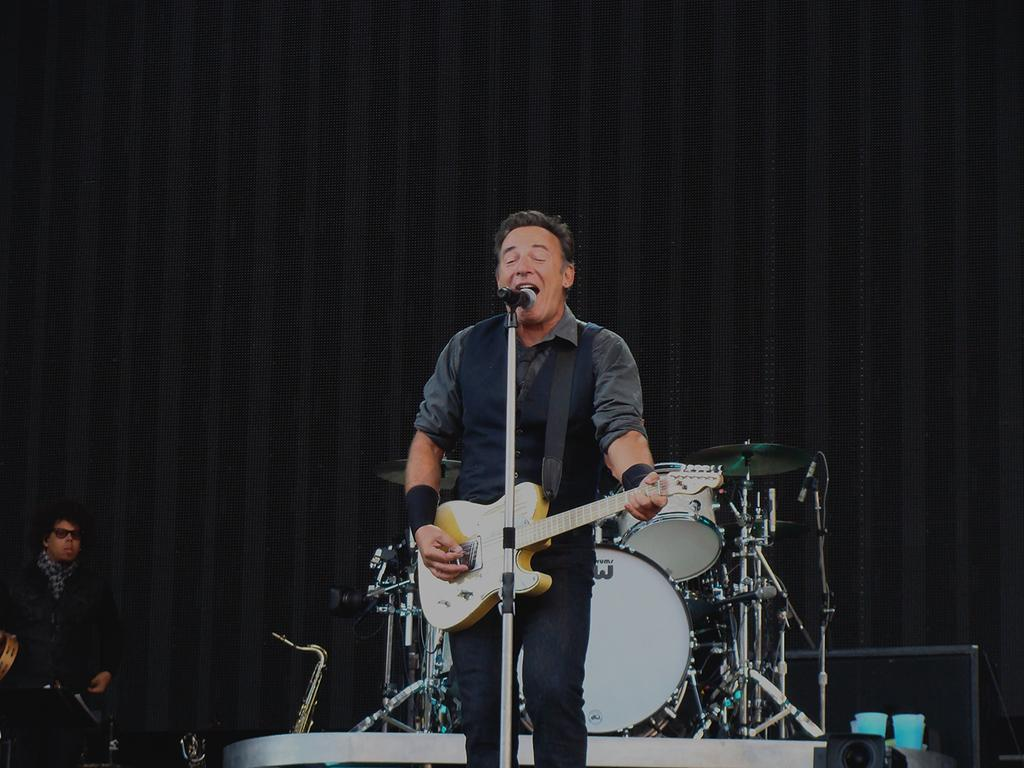What is the man in the image doing? The man is singing in the image. What is the man holding while singing? The man is holding a microphone in front of him. What instrument is the man playing? The man is playing a guitar. What type of sheet is the man using to cover the guitar in the image? There is no sheet present in the image, and the guitar is not being covered. 